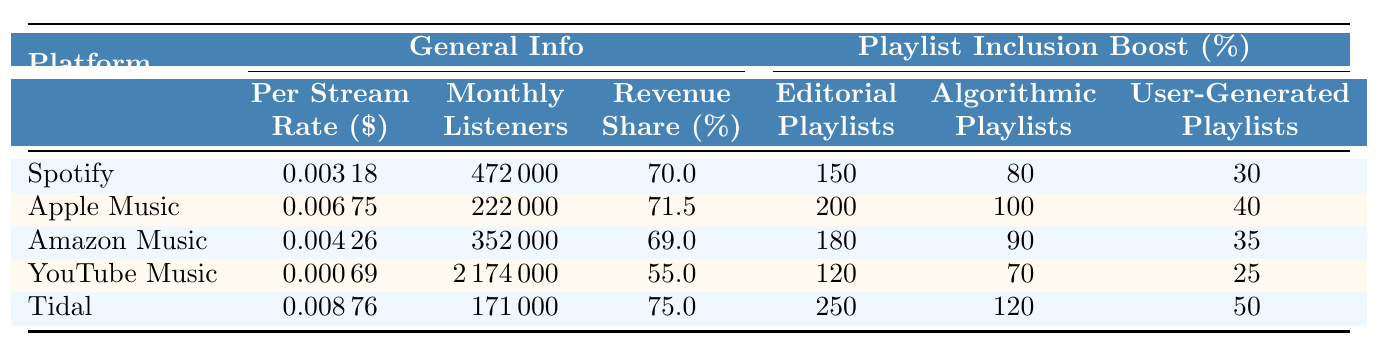What is the per stream rate for Tidal? According to the table, the rate listed under Tidal specifically states $0.00876 as the per stream rate.
Answer: $0.00876 How many monthly listeners are required for minimum wage on Spotify? By referring to the Spotify row, it indicates that 472,000 monthly listeners are required for minimum wage.
Answer: 472,000 Which platform has the highest revenue share percentage? The revenue share percentages were checked for each platform, and Tidal shows the highest at 75%.
Answer: Tidal What is the difference in per stream rates between Apple Music and YouTube Music? By subtracting the per stream rate of YouTube Music ($0.00069) from that of Apple Music ($0.00675), the difference is $0.00675 - $0.00069 = $0.00606.
Answer: $0.00606 True or False: Amazon Music offers a 90% boost for algorithmic playlists. The table shows that Amazon Music has an 80% boost for algorithmic playlists, so this statement is false.
Answer: False If an artist only appears in user-generated playlists on Spotify, what percentage boost do they receive? The table states that for user-generated playlists on Spotify, there is a 30% boost.
Answer: 30% What is the average per stream rate among all listed platforms? To find the average, we add all the per stream rates: $0.00318 (Spotify) + $0.00675 (Apple Music) + $0.00426 (Amazon Music) + $0.00069 (YouTube Music) + $0.00876 (Tidal) = $0.02394. We then divide by 5 platforms: $0.02394 / 5 = $0.004788.
Answer: $0.00479 If an artist wants to earn minimum wage on YouTube Music, how many more monthly listeners do they need compared to those needed for Apple Music? YouTube Music needs 2,174,000 monthly listeners while Apple Music needs 222,000. The difference is 2,174,000 - 222,000 = 1,952,000.
Answer: 1,952,000 Which platform requires the fewest monthly listeners to reach minimum wage? The monthly listeners required for minimum wage was checked: Spotify (472,000), Apple Music (222,000), Amazon Music (352,000), YouTube Music (2,174,000), and Tidal (171,000). Apple Music requires the fewest at 222,000.
Answer: Apple Music What percentage boost does Tidal provide for editorial playlists? The table indicates that Tidal offers a significant boost of 250% for editorial playlists.
Answer: 250% Which platform has the lowest per stream rate? By reviewing the per stream rates, YouTube Music has the lowest at $0.00069.
Answer: YouTube Music 